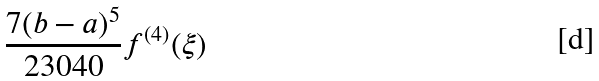Convert formula to latex. <formula><loc_0><loc_0><loc_500><loc_500>\frac { 7 ( b - a ) ^ { 5 } } { 2 3 0 4 0 } f ^ { ( 4 ) } ( \xi )</formula> 